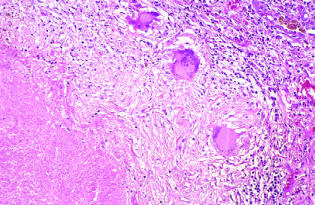what does the granulomatous response take the form of?
Answer the question using a single word or phrase. A three-dimensional sphere 